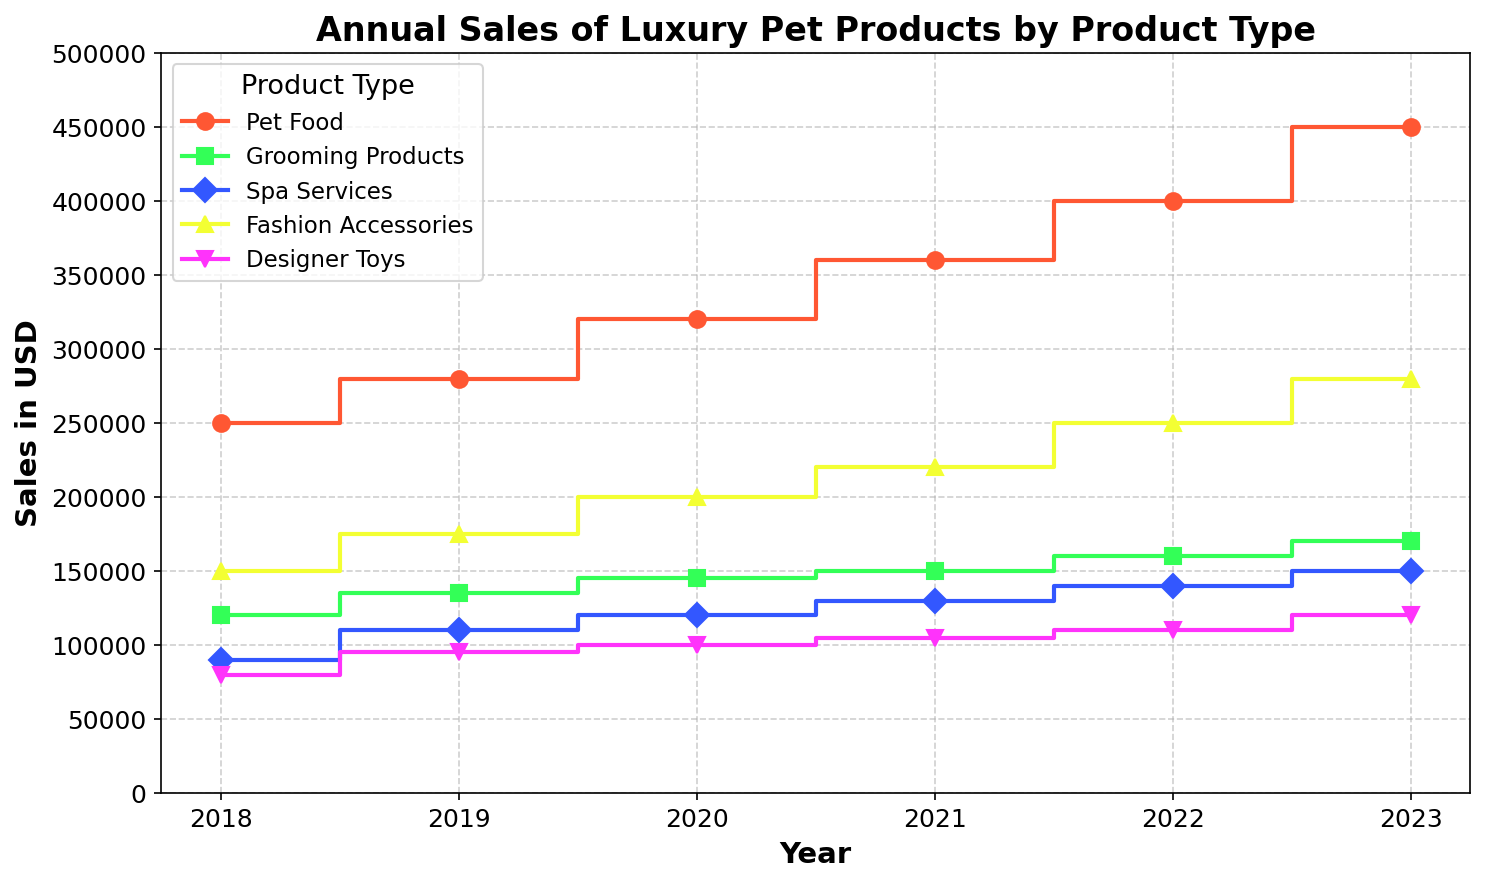what was the highest value of sales achieved in 2023 and by which product type? By looking at the step plot, we see the highest value in 2023 was by Pet Food. The Pet Food line in 2023 reaches 450,000, which is higher than any other product lines.
Answer: 450,000, Pet Food How did the sales of Grooming Products change from 2018 to 2023? Starting at 120,000 in 2018, Grooming Products reached 170,000 in 2023. The difference is 170,000 - 120,000 = 50,000. Thus, the sales increased by 50,000 over this period.
Answer: Increased by 50,000 Which year had the highest combined sales of Spa Services and Fashion Accessories? Add the sales values of Spa Services and Fashion Accessories for each year: 
2018: 90,000+150,000 = 240,000
2019: 110,000+175,000 = 285,000
2020: 120,000+200,000 = 320,000
2021: 130,000+220,000 = 350,000
2022: 140,000+250,000 = 390,000
2023: 150,000+280,000 = 430,000
The highest combined sales occur in 2023.
Answer: 2023 Which product type had the least variation in sales between 2018 and 2023? Calculate the difference between the highest and lowest sales for each product:
 - Pet Food: 450,000 - 250,000 = 200,000
 - Grooming Products: 170,000 - 120,000 = 50,000
 - Spa Services: 150,000 - 90,000 = 60,000
 - Fashion Accessories: 280,000 - 150,000 = 130,000
 - Designer Toys: 120,000 - 80,000 = 40,000.
Designer Toys had the least variation in sales.
Answer: Designer Toys In 2022, which product type surpassed its previous year's sales by the largest amount? Compare the sales between 2021 and 2022 for each product type:
 - Pet Food: 400,000 - 360,000 = 40,000
 - Grooming Products: 160,000 - 150,000 = 10,000
 - Spa Services: 140,000 - 130,000 = 10,000
 - Fashion Accessories: 250,000 - 220,000 = 30,000
 - Designer Toys: 110,000 - 105,000 = 5,000.
Pet Food had the largest increase of 40,000 from 2021 to 2022.
Answer: Pet Food Between 2018 and 2023, which year saw the smallest total sales across all product categories? Add total sales for each year:
2018: 250,000+120,000+90,000+150,000+80,000 = 690,000
2019: 280,000+135,000+110,000+175,000+95,000 = 795,000
2020: 320,000+145,000+120,000+200,000+100,000 = 885,000
2021: 360,000+150,000+130,000+220,000+105,000 = 965,000
2022: 400,000+160,000+140,000+250,000+110,000 = 1,060,000
2023: 450,000+170,000+150,000+280,000+120,000 = 1,170,000.
2018 saw the smallest total sales.
Answer: 2018 Which product type had the most consistent year-on-year growth? Examine the increments year-over-year for each product. Pet Food shows the most consistent growth, with increases at:
 - 2018 to 2019: 30,000
 - 2019 to 2020: 40,000
 - 2020 to 2021: 40,000
 - 2021 to 2022: 40,000
 - 2022 to 2023: 50,000.
The variation in the increases for Pet Food is small and systematic.
Answer: Pet Food How much more were the total sales in 2023 compared to 2018 across all product types? Sum the total sales for 2023 and 2018:
2023: 450,000+170,000+150,000+280,000+120,000 = 1,170,000
2018: 250,000+120,000+90,000+150,000+80,000 = 690,000.
1,170,000 - 690,000 = 480,000, so the total sales in 2023 were 480,000 more than in 2018.
Answer: 480,000 